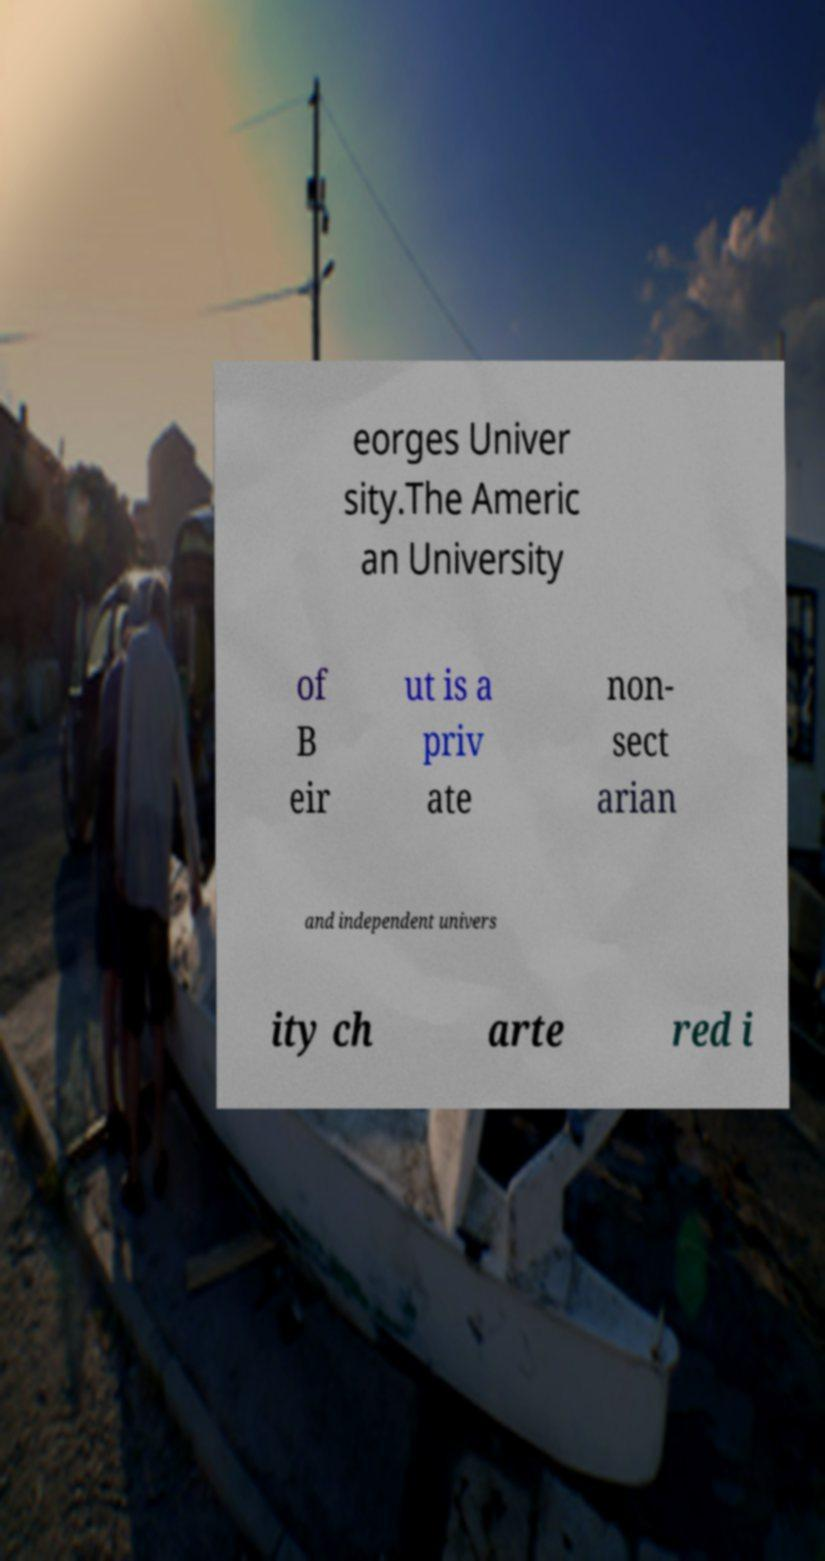Please identify and transcribe the text found in this image. eorges Univer sity.The Americ an University of B eir ut is a priv ate non- sect arian and independent univers ity ch arte red i 